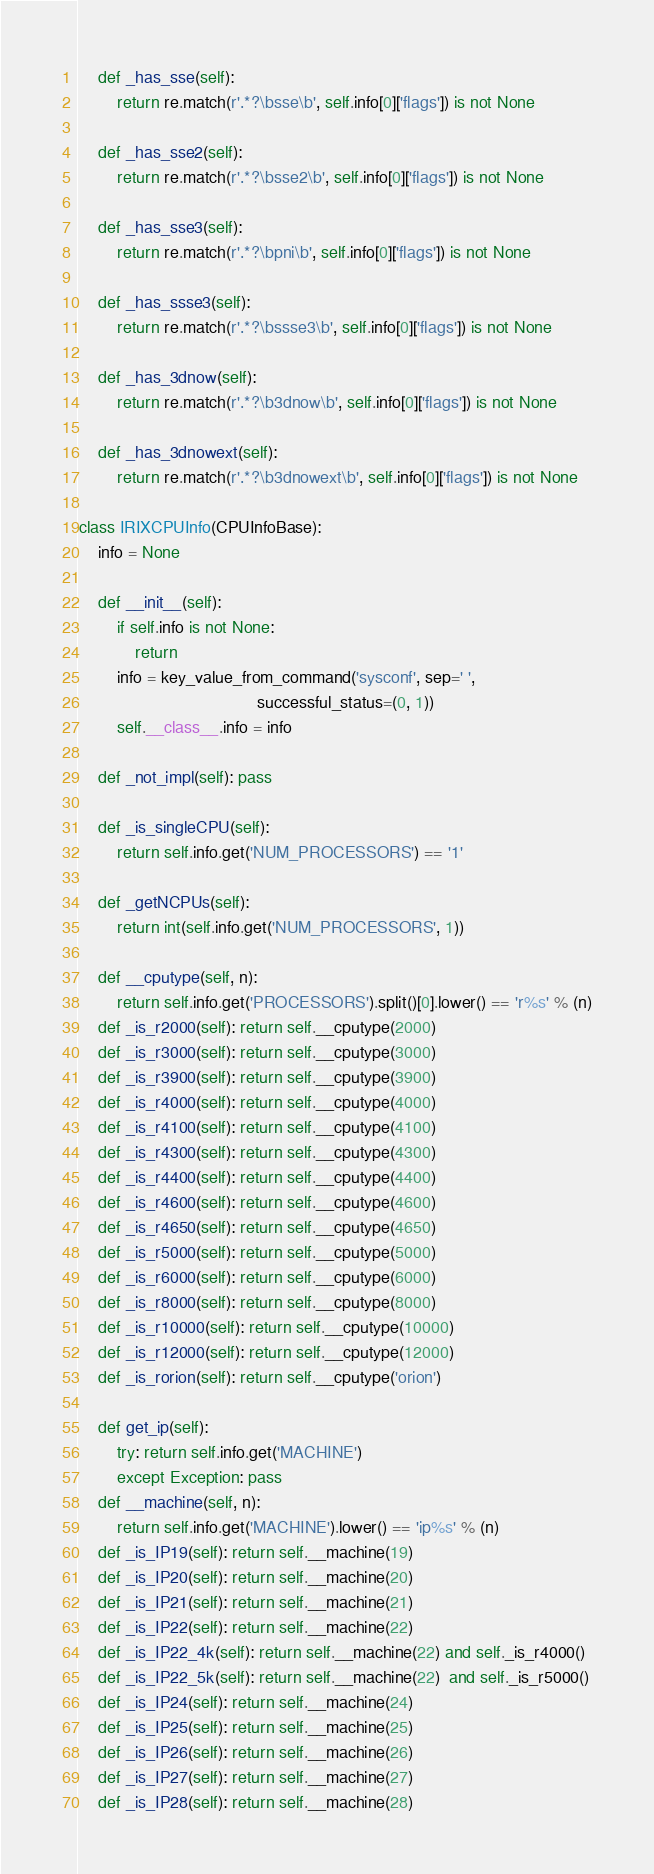<code> <loc_0><loc_0><loc_500><loc_500><_Python_>    def _has_sse(self):
        return re.match(r'.*?\bsse\b', self.info[0]['flags']) is not None

    def _has_sse2(self):
        return re.match(r'.*?\bsse2\b', self.info[0]['flags']) is not None

    def _has_sse3(self):
        return re.match(r'.*?\bpni\b', self.info[0]['flags']) is not None

    def _has_ssse3(self):
        return re.match(r'.*?\bssse3\b', self.info[0]['flags']) is not None

    def _has_3dnow(self):
        return re.match(r'.*?\b3dnow\b', self.info[0]['flags']) is not None

    def _has_3dnowext(self):
        return re.match(r'.*?\b3dnowext\b', self.info[0]['flags']) is not None

class IRIXCPUInfo(CPUInfoBase):
    info = None

    def __init__(self):
        if self.info is not None:
            return
        info = key_value_from_command('sysconf', sep=' ',
                                      successful_status=(0, 1))
        self.__class__.info = info

    def _not_impl(self): pass

    def _is_singleCPU(self):
        return self.info.get('NUM_PROCESSORS') == '1'

    def _getNCPUs(self):
        return int(self.info.get('NUM_PROCESSORS', 1))

    def __cputype(self, n):
        return self.info.get('PROCESSORS').split()[0].lower() == 'r%s' % (n)
    def _is_r2000(self): return self.__cputype(2000)
    def _is_r3000(self): return self.__cputype(3000)
    def _is_r3900(self): return self.__cputype(3900)
    def _is_r4000(self): return self.__cputype(4000)
    def _is_r4100(self): return self.__cputype(4100)
    def _is_r4300(self): return self.__cputype(4300)
    def _is_r4400(self): return self.__cputype(4400)
    def _is_r4600(self): return self.__cputype(4600)
    def _is_r4650(self): return self.__cputype(4650)
    def _is_r5000(self): return self.__cputype(5000)
    def _is_r6000(self): return self.__cputype(6000)
    def _is_r8000(self): return self.__cputype(8000)
    def _is_r10000(self): return self.__cputype(10000)
    def _is_r12000(self): return self.__cputype(12000)
    def _is_rorion(self): return self.__cputype('orion')

    def get_ip(self):
        try: return self.info.get('MACHINE')
        except Exception: pass
    def __machine(self, n):
        return self.info.get('MACHINE').lower() == 'ip%s' % (n)
    def _is_IP19(self): return self.__machine(19)
    def _is_IP20(self): return self.__machine(20)
    def _is_IP21(self): return self.__machine(21)
    def _is_IP22(self): return self.__machine(22)
    def _is_IP22_4k(self): return self.__machine(22) and self._is_r4000()
    def _is_IP22_5k(self): return self.__machine(22)  and self._is_r5000()
    def _is_IP24(self): return self.__machine(24)
    def _is_IP25(self): return self.__machine(25)
    def _is_IP26(self): return self.__machine(26)
    def _is_IP27(self): return self.__machine(27)
    def _is_IP28(self): return self.__machine(28)</code> 